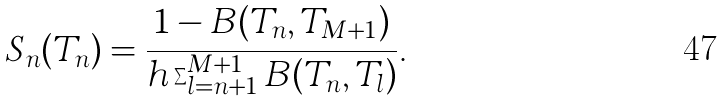<formula> <loc_0><loc_0><loc_500><loc_500>S _ { n } ( T _ { n } ) = \frac { 1 - B ( T _ { n } , T _ { M + 1 } ) } { h \sum _ { l = n + 1 } ^ { M + 1 } B ( T _ { n } , T _ { l } ) } .</formula> 